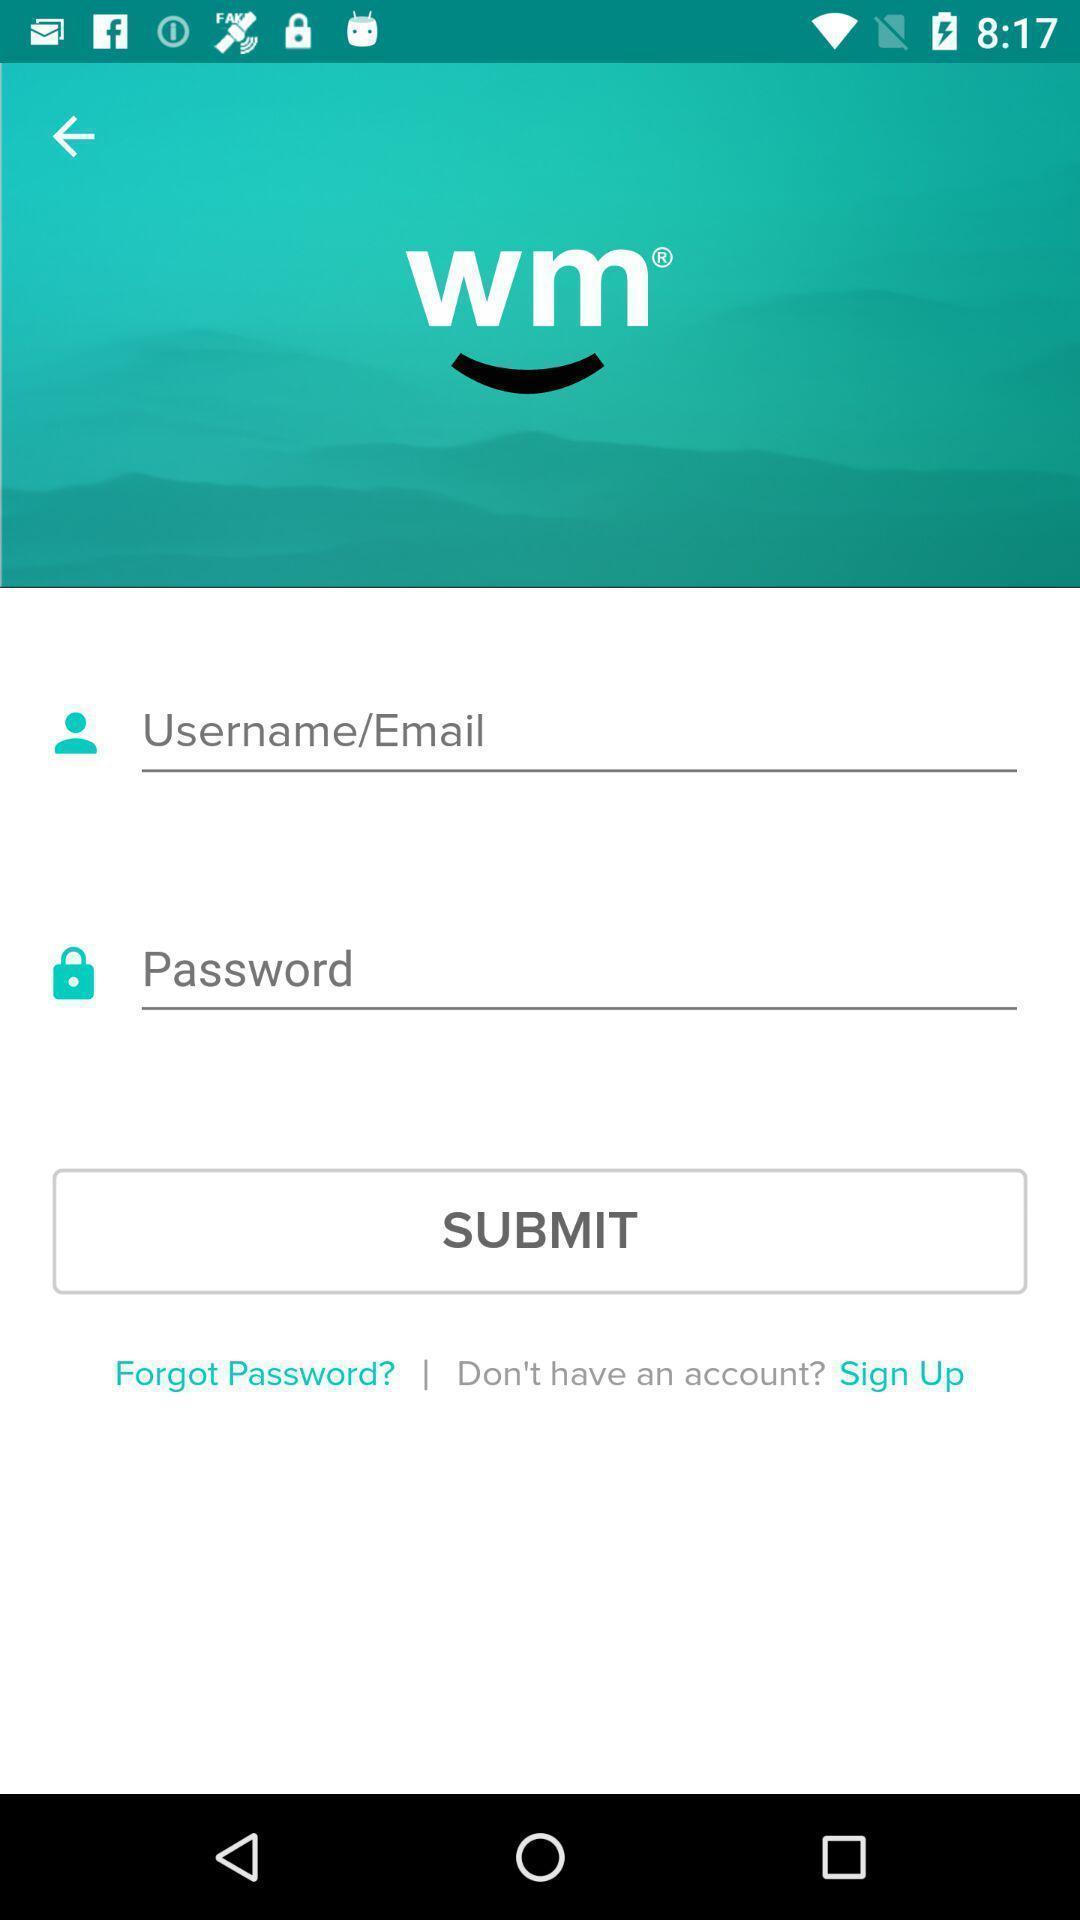Describe the key features of this screenshot. Sign in page. 